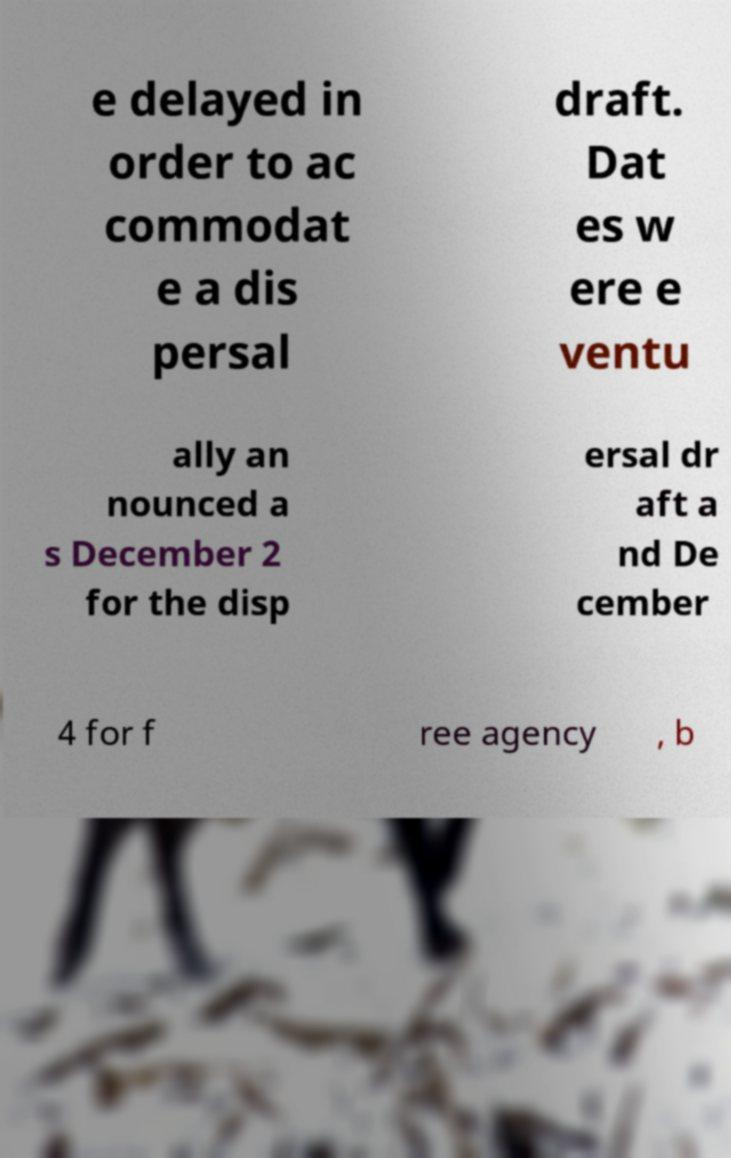Can you read and provide the text displayed in the image?This photo seems to have some interesting text. Can you extract and type it out for me? e delayed in order to ac commodat e a dis persal draft. Dat es w ere e ventu ally an nounced a s December 2 for the disp ersal dr aft a nd De cember 4 for f ree agency , b 